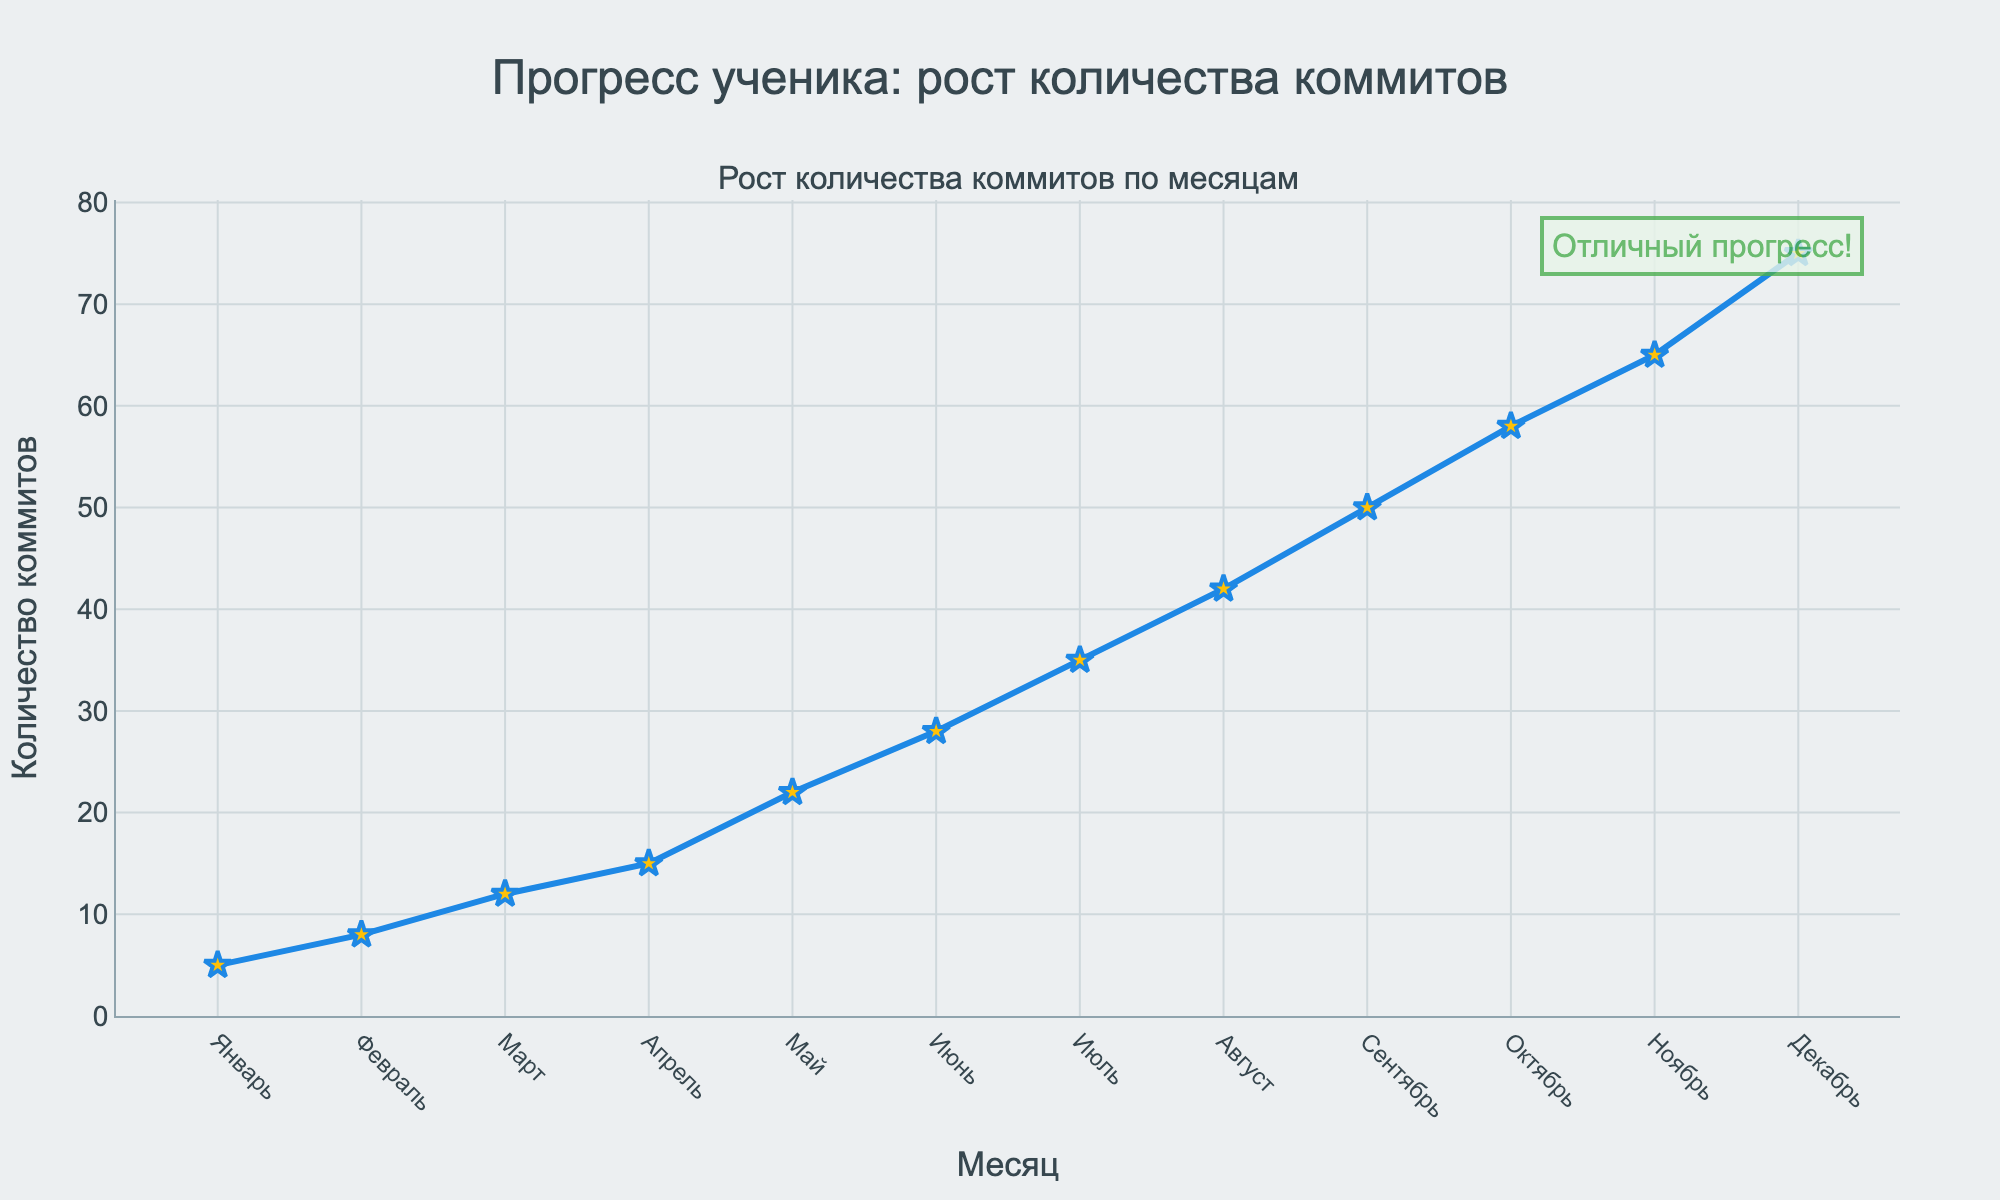What is the total number of commits in the first quarter (Январь to Март)? Sum the commits in Январь (5), Февраль (8), and Март (12). 5 + 8 + 12 = 25
Answer: 25 In which month did the number of commits see the biggest increase compared to the previous month? From the figure, find the highest difference between consecutive months. Май (22) - Апрель (15) = 7, then Июнь (28) - Май (22) = 6, Июль (35) - Июнь (28) = 7, Август (42) - Июль (35) = 7, Сентябрь (50) - Август (42) = 8, Октябрь (58) - Сентябрь (50) = 8, Ноябрь (65) - Октябрь (58) = 7, Декабрь (75) - Ноябрь (65) = 10, 最大 прирост между Ноябрь и Декабрь.
Answer: Декабрь How many commits were made in the second half of the year (Июль to Декабрь)? Sum the commits from Июль (35), Август (42), Сентябрь (50), Октябрь (58), Ноябрь (65), Декабрь (75). 35 + 42 + 50 + 58 + 65 + 75 = 325
Answer: 325 What is the average number of commits per month? Sum all commits and divide by 12. (5 + 8 + 12 + 15 + 22 + 28 + 35 + 42 + 50 + 58 + 65 + 75) / 12 = 415 / 12 = 34.58
Answer: 34.58 Which month had the fewest commits? Identify the lowest point on the chart, which corresponds to Январь (5 commits).
Answer: Январь What is the difference in the number of commits from Январь to Декабрь? Subtract the number of commits in Январь (5) from those in Декабрь (75). 75 - 5 = 70
Answer: 70 In which trimester (group of three months) did the number of commits grow the fastest? Calculate the increase in each trimester and compare. Январь-Март: 5 + 8 + 12 = 25, Апрель-Июнь: 15 + 22 + 28 = 65, Июль-Сентябрь: 35 + 42 + 50 = 127, Октябрь-Декабрь: 58 + 65 + 75 = 198. The highest increase is in the last trimester.
Answer: Октябрь-Декабрь 